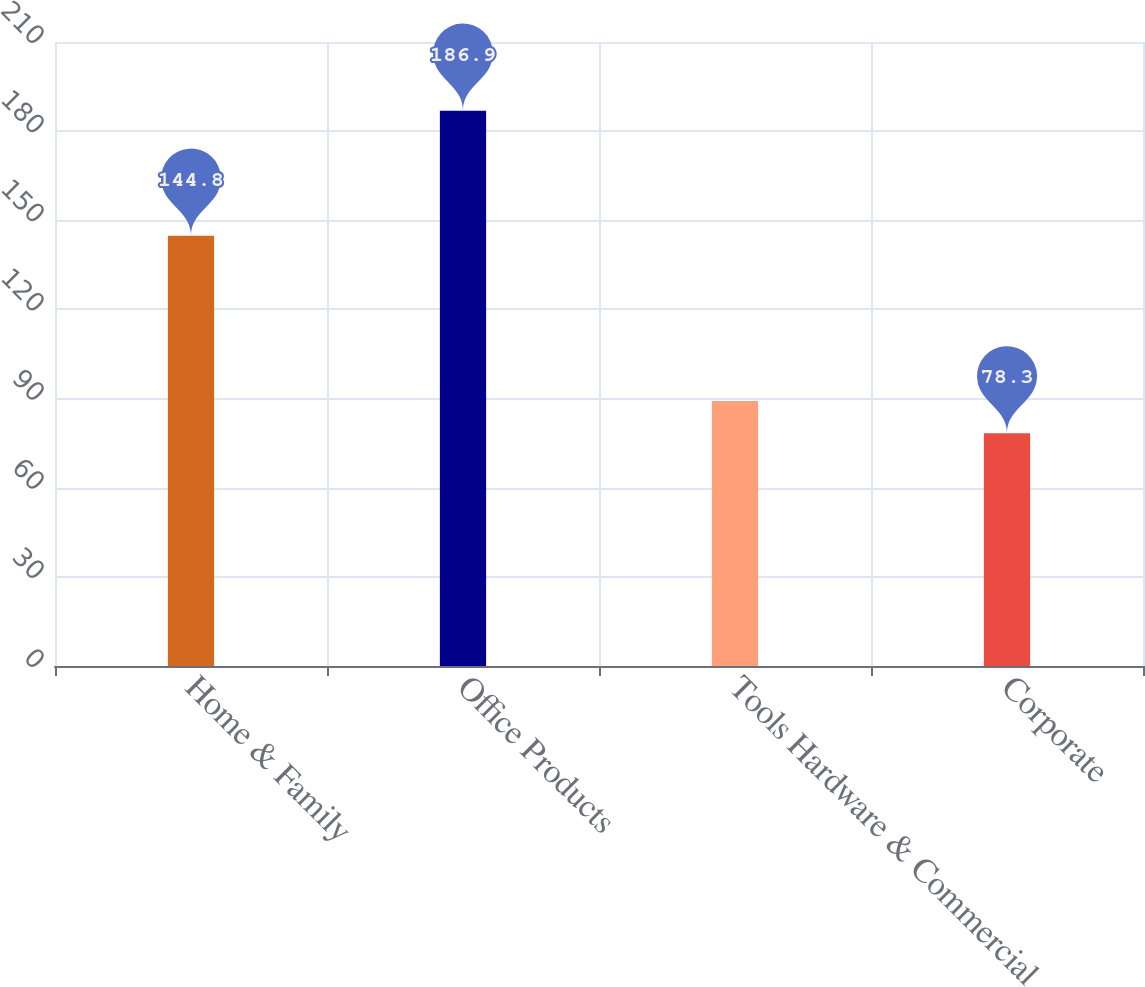Convert chart. <chart><loc_0><loc_0><loc_500><loc_500><bar_chart><fcel>Home & Family<fcel>Office Products<fcel>Tools Hardware & Commercial<fcel>Corporate<nl><fcel>144.8<fcel>186.9<fcel>89.16<fcel>78.3<nl></chart> 